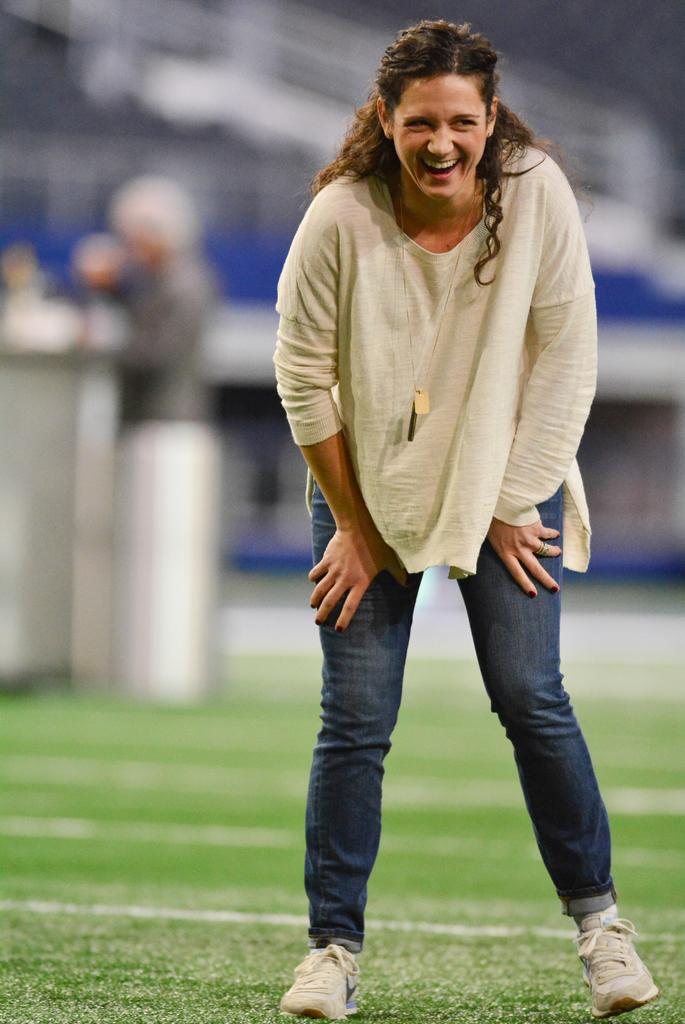Who is the main subject in the image? There is a woman in the image. What is the woman's position in relation to the ground? The woman is standing on the ground. Can you describe the background of the image? The background of the image is blurry. How many loaves of bread can be seen in the image? There are no loaves of bread present in the image. What type of rabbits are visible in the image? There are no rabbits present in the image. 